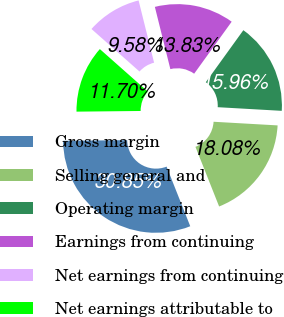Convert chart to OTSL. <chart><loc_0><loc_0><loc_500><loc_500><pie_chart><fcel>Gross margin<fcel>Selling general and<fcel>Operating margin<fcel>Earnings from continuing<fcel>Net earnings from continuing<fcel>Net earnings attributable to<nl><fcel>30.85%<fcel>18.08%<fcel>15.96%<fcel>13.83%<fcel>9.58%<fcel>11.7%<nl></chart> 